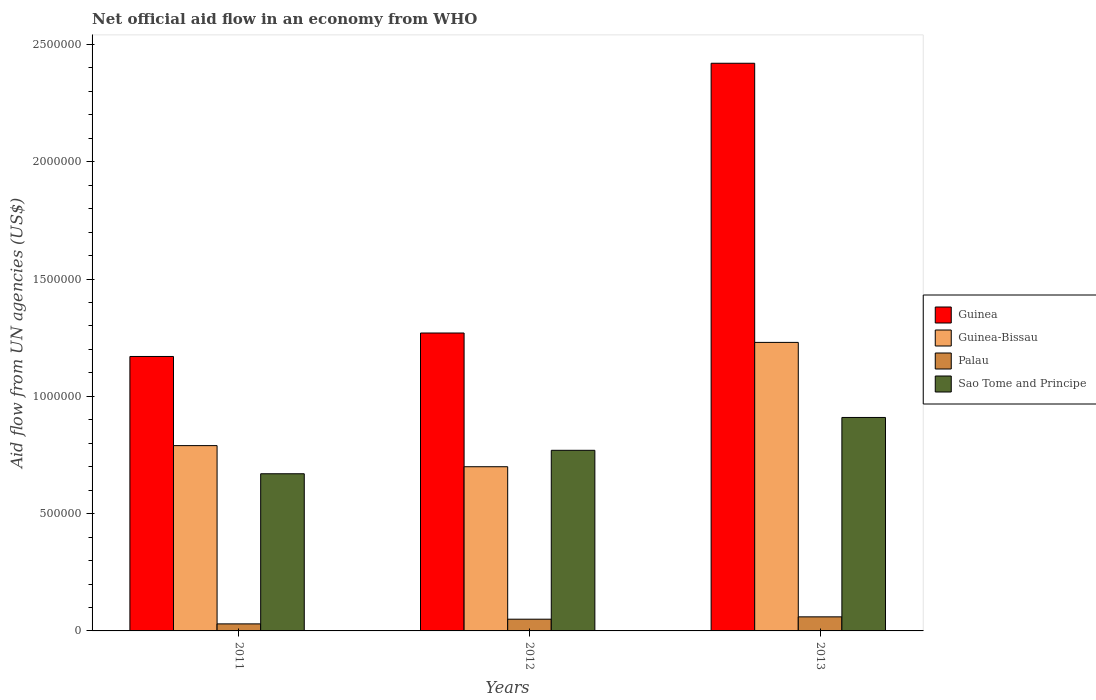How many bars are there on the 1st tick from the right?
Offer a terse response. 4. What is the net official aid flow in Guinea in 2012?
Your answer should be very brief. 1.27e+06. Across all years, what is the maximum net official aid flow in Sao Tome and Principe?
Offer a very short reply. 9.10e+05. Across all years, what is the minimum net official aid flow in Guinea?
Offer a terse response. 1.17e+06. In which year was the net official aid flow in Guinea maximum?
Your response must be concise. 2013. What is the total net official aid flow in Guinea in the graph?
Offer a very short reply. 4.86e+06. What is the difference between the net official aid flow in Guinea-Bissau in 2011 and that in 2013?
Make the answer very short. -4.40e+05. What is the difference between the net official aid flow in Guinea in 2011 and the net official aid flow in Palau in 2013?
Make the answer very short. 1.11e+06. What is the average net official aid flow in Guinea-Bissau per year?
Keep it short and to the point. 9.07e+05. In the year 2011, what is the difference between the net official aid flow in Guinea-Bissau and net official aid flow in Palau?
Offer a very short reply. 7.60e+05. What is the ratio of the net official aid flow in Palau in 2012 to that in 2013?
Offer a very short reply. 0.83. Is the difference between the net official aid flow in Guinea-Bissau in 2012 and 2013 greater than the difference between the net official aid flow in Palau in 2012 and 2013?
Provide a succinct answer. No. What is the difference between the highest and the second highest net official aid flow in Sao Tome and Principe?
Offer a terse response. 1.40e+05. What is the difference between the highest and the lowest net official aid flow in Guinea-Bissau?
Give a very brief answer. 5.30e+05. Is it the case that in every year, the sum of the net official aid flow in Guinea-Bissau and net official aid flow in Sao Tome and Principe is greater than the sum of net official aid flow in Palau and net official aid flow in Guinea?
Your response must be concise. Yes. What does the 3rd bar from the left in 2011 represents?
Keep it short and to the point. Palau. What does the 3rd bar from the right in 2013 represents?
Give a very brief answer. Guinea-Bissau. Is it the case that in every year, the sum of the net official aid flow in Guinea-Bissau and net official aid flow in Guinea is greater than the net official aid flow in Palau?
Make the answer very short. Yes. How many bars are there?
Your response must be concise. 12. What is the difference between two consecutive major ticks on the Y-axis?
Provide a succinct answer. 5.00e+05. Are the values on the major ticks of Y-axis written in scientific E-notation?
Offer a very short reply. No. Where does the legend appear in the graph?
Keep it short and to the point. Center right. How are the legend labels stacked?
Ensure brevity in your answer.  Vertical. What is the title of the graph?
Make the answer very short. Net official aid flow in an economy from WHO. Does "Philippines" appear as one of the legend labels in the graph?
Give a very brief answer. No. What is the label or title of the X-axis?
Your answer should be compact. Years. What is the label or title of the Y-axis?
Provide a short and direct response. Aid flow from UN agencies (US$). What is the Aid flow from UN agencies (US$) in Guinea in 2011?
Your answer should be very brief. 1.17e+06. What is the Aid flow from UN agencies (US$) in Guinea-Bissau in 2011?
Your answer should be compact. 7.90e+05. What is the Aid flow from UN agencies (US$) in Sao Tome and Principe in 2011?
Ensure brevity in your answer.  6.70e+05. What is the Aid flow from UN agencies (US$) of Guinea in 2012?
Your answer should be compact. 1.27e+06. What is the Aid flow from UN agencies (US$) in Guinea-Bissau in 2012?
Provide a succinct answer. 7.00e+05. What is the Aid flow from UN agencies (US$) of Sao Tome and Principe in 2012?
Provide a short and direct response. 7.70e+05. What is the Aid flow from UN agencies (US$) of Guinea in 2013?
Keep it short and to the point. 2.42e+06. What is the Aid flow from UN agencies (US$) of Guinea-Bissau in 2013?
Provide a succinct answer. 1.23e+06. What is the Aid flow from UN agencies (US$) in Palau in 2013?
Provide a short and direct response. 6.00e+04. What is the Aid flow from UN agencies (US$) in Sao Tome and Principe in 2013?
Give a very brief answer. 9.10e+05. Across all years, what is the maximum Aid flow from UN agencies (US$) of Guinea?
Provide a short and direct response. 2.42e+06. Across all years, what is the maximum Aid flow from UN agencies (US$) in Guinea-Bissau?
Your answer should be compact. 1.23e+06. Across all years, what is the maximum Aid flow from UN agencies (US$) of Sao Tome and Principe?
Your answer should be compact. 9.10e+05. Across all years, what is the minimum Aid flow from UN agencies (US$) of Guinea?
Your answer should be very brief. 1.17e+06. Across all years, what is the minimum Aid flow from UN agencies (US$) in Guinea-Bissau?
Give a very brief answer. 7.00e+05. Across all years, what is the minimum Aid flow from UN agencies (US$) of Palau?
Keep it short and to the point. 3.00e+04. Across all years, what is the minimum Aid flow from UN agencies (US$) in Sao Tome and Principe?
Keep it short and to the point. 6.70e+05. What is the total Aid flow from UN agencies (US$) in Guinea in the graph?
Provide a short and direct response. 4.86e+06. What is the total Aid flow from UN agencies (US$) in Guinea-Bissau in the graph?
Provide a short and direct response. 2.72e+06. What is the total Aid flow from UN agencies (US$) of Sao Tome and Principe in the graph?
Provide a short and direct response. 2.35e+06. What is the difference between the Aid flow from UN agencies (US$) in Guinea in 2011 and that in 2012?
Provide a succinct answer. -1.00e+05. What is the difference between the Aid flow from UN agencies (US$) in Palau in 2011 and that in 2012?
Provide a succinct answer. -2.00e+04. What is the difference between the Aid flow from UN agencies (US$) in Guinea in 2011 and that in 2013?
Your answer should be compact. -1.25e+06. What is the difference between the Aid flow from UN agencies (US$) of Guinea-Bissau in 2011 and that in 2013?
Give a very brief answer. -4.40e+05. What is the difference between the Aid flow from UN agencies (US$) of Palau in 2011 and that in 2013?
Offer a very short reply. -3.00e+04. What is the difference between the Aid flow from UN agencies (US$) in Guinea in 2012 and that in 2013?
Provide a short and direct response. -1.15e+06. What is the difference between the Aid flow from UN agencies (US$) of Guinea-Bissau in 2012 and that in 2013?
Make the answer very short. -5.30e+05. What is the difference between the Aid flow from UN agencies (US$) of Palau in 2012 and that in 2013?
Give a very brief answer. -10000. What is the difference between the Aid flow from UN agencies (US$) of Guinea in 2011 and the Aid flow from UN agencies (US$) of Guinea-Bissau in 2012?
Ensure brevity in your answer.  4.70e+05. What is the difference between the Aid flow from UN agencies (US$) of Guinea in 2011 and the Aid flow from UN agencies (US$) of Palau in 2012?
Your answer should be compact. 1.12e+06. What is the difference between the Aid flow from UN agencies (US$) of Guinea in 2011 and the Aid flow from UN agencies (US$) of Sao Tome and Principe in 2012?
Ensure brevity in your answer.  4.00e+05. What is the difference between the Aid flow from UN agencies (US$) of Guinea-Bissau in 2011 and the Aid flow from UN agencies (US$) of Palau in 2012?
Your answer should be very brief. 7.40e+05. What is the difference between the Aid flow from UN agencies (US$) of Palau in 2011 and the Aid flow from UN agencies (US$) of Sao Tome and Principe in 2012?
Ensure brevity in your answer.  -7.40e+05. What is the difference between the Aid flow from UN agencies (US$) of Guinea in 2011 and the Aid flow from UN agencies (US$) of Guinea-Bissau in 2013?
Your answer should be compact. -6.00e+04. What is the difference between the Aid flow from UN agencies (US$) of Guinea in 2011 and the Aid flow from UN agencies (US$) of Palau in 2013?
Keep it short and to the point. 1.11e+06. What is the difference between the Aid flow from UN agencies (US$) in Guinea in 2011 and the Aid flow from UN agencies (US$) in Sao Tome and Principe in 2013?
Your answer should be compact. 2.60e+05. What is the difference between the Aid flow from UN agencies (US$) of Guinea-Bissau in 2011 and the Aid flow from UN agencies (US$) of Palau in 2013?
Keep it short and to the point. 7.30e+05. What is the difference between the Aid flow from UN agencies (US$) in Palau in 2011 and the Aid flow from UN agencies (US$) in Sao Tome and Principe in 2013?
Your answer should be compact. -8.80e+05. What is the difference between the Aid flow from UN agencies (US$) in Guinea in 2012 and the Aid flow from UN agencies (US$) in Palau in 2013?
Offer a terse response. 1.21e+06. What is the difference between the Aid flow from UN agencies (US$) of Guinea in 2012 and the Aid flow from UN agencies (US$) of Sao Tome and Principe in 2013?
Your answer should be compact. 3.60e+05. What is the difference between the Aid flow from UN agencies (US$) of Guinea-Bissau in 2012 and the Aid flow from UN agencies (US$) of Palau in 2013?
Your answer should be compact. 6.40e+05. What is the difference between the Aid flow from UN agencies (US$) in Guinea-Bissau in 2012 and the Aid flow from UN agencies (US$) in Sao Tome and Principe in 2013?
Make the answer very short. -2.10e+05. What is the difference between the Aid flow from UN agencies (US$) in Palau in 2012 and the Aid flow from UN agencies (US$) in Sao Tome and Principe in 2013?
Provide a short and direct response. -8.60e+05. What is the average Aid flow from UN agencies (US$) of Guinea per year?
Offer a terse response. 1.62e+06. What is the average Aid flow from UN agencies (US$) of Guinea-Bissau per year?
Offer a terse response. 9.07e+05. What is the average Aid flow from UN agencies (US$) in Palau per year?
Your answer should be compact. 4.67e+04. What is the average Aid flow from UN agencies (US$) of Sao Tome and Principe per year?
Your answer should be compact. 7.83e+05. In the year 2011, what is the difference between the Aid flow from UN agencies (US$) in Guinea and Aid flow from UN agencies (US$) in Palau?
Your response must be concise. 1.14e+06. In the year 2011, what is the difference between the Aid flow from UN agencies (US$) in Guinea and Aid flow from UN agencies (US$) in Sao Tome and Principe?
Keep it short and to the point. 5.00e+05. In the year 2011, what is the difference between the Aid flow from UN agencies (US$) of Guinea-Bissau and Aid flow from UN agencies (US$) of Palau?
Your response must be concise. 7.60e+05. In the year 2011, what is the difference between the Aid flow from UN agencies (US$) of Palau and Aid flow from UN agencies (US$) of Sao Tome and Principe?
Provide a short and direct response. -6.40e+05. In the year 2012, what is the difference between the Aid flow from UN agencies (US$) of Guinea and Aid flow from UN agencies (US$) of Guinea-Bissau?
Your response must be concise. 5.70e+05. In the year 2012, what is the difference between the Aid flow from UN agencies (US$) of Guinea and Aid flow from UN agencies (US$) of Palau?
Offer a terse response. 1.22e+06. In the year 2012, what is the difference between the Aid flow from UN agencies (US$) in Guinea and Aid flow from UN agencies (US$) in Sao Tome and Principe?
Give a very brief answer. 5.00e+05. In the year 2012, what is the difference between the Aid flow from UN agencies (US$) of Guinea-Bissau and Aid flow from UN agencies (US$) of Palau?
Your answer should be compact. 6.50e+05. In the year 2012, what is the difference between the Aid flow from UN agencies (US$) of Palau and Aid flow from UN agencies (US$) of Sao Tome and Principe?
Offer a terse response. -7.20e+05. In the year 2013, what is the difference between the Aid flow from UN agencies (US$) of Guinea and Aid flow from UN agencies (US$) of Guinea-Bissau?
Keep it short and to the point. 1.19e+06. In the year 2013, what is the difference between the Aid flow from UN agencies (US$) of Guinea and Aid flow from UN agencies (US$) of Palau?
Keep it short and to the point. 2.36e+06. In the year 2013, what is the difference between the Aid flow from UN agencies (US$) in Guinea and Aid flow from UN agencies (US$) in Sao Tome and Principe?
Ensure brevity in your answer.  1.51e+06. In the year 2013, what is the difference between the Aid flow from UN agencies (US$) of Guinea-Bissau and Aid flow from UN agencies (US$) of Palau?
Give a very brief answer. 1.17e+06. In the year 2013, what is the difference between the Aid flow from UN agencies (US$) of Guinea-Bissau and Aid flow from UN agencies (US$) of Sao Tome and Principe?
Your answer should be compact. 3.20e+05. In the year 2013, what is the difference between the Aid flow from UN agencies (US$) in Palau and Aid flow from UN agencies (US$) in Sao Tome and Principe?
Provide a succinct answer. -8.50e+05. What is the ratio of the Aid flow from UN agencies (US$) of Guinea in 2011 to that in 2012?
Your answer should be compact. 0.92. What is the ratio of the Aid flow from UN agencies (US$) in Guinea-Bissau in 2011 to that in 2012?
Ensure brevity in your answer.  1.13. What is the ratio of the Aid flow from UN agencies (US$) in Palau in 2011 to that in 2012?
Keep it short and to the point. 0.6. What is the ratio of the Aid flow from UN agencies (US$) of Sao Tome and Principe in 2011 to that in 2012?
Provide a succinct answer. 0.87. What is the ratio of the Aid flow from UN agencies (US$) in Guinea in 2011 to that in 2013?
Keep it short and to the point. 0.48. What is the ratio of the Aid flow from UN agencies (US$) in Guinea-Bissau in 2011 to that in 2013?
Provide a succinct answer. 0.64. What is the ratio of the Aid flow from UN agencies (US$) in Palau in 2011 to that in 2013?
Your answer should be very brief. 0.5. What is the ratio of the Aid flow from UN agencies (US$) in Sao Tome and Principe in 2011 to that in 2013?
Provide a short and direct response. 0.74. What is the ratio of the Aid flow from UN agencies (US$) in Guinea in 2012 to that in 2013?
Your answer should be very brief. 0.52. What is the ratio of the Aid flow from UN agencies (US$) in Guinea-Bissau in 2012 to that in 2013?
Give a very brief answer. 0.57. What is the ratio of the Aid flow from UN agencies (US$) in Palau in 2012 to that in 2013?
Ensure brevity in your answer.  0.83. What is the ratio of the Aid flow from UN agencies (US$) of Sao Tome and Principe in 2012 to that in 2013?
Your answer should be very brief. 0.85. What is the difference between the highest and the second highest Aid flow from UN agencies (US$) in Guinea?
Ensure brevity in your answer.  1.15e+06. What is the difference between the highest and the second highest Aid flow from UN agencies (US$) of Guinea-Bissau?
Keep it short and to the point. 4.40e+05. What is the difference between the highest and the lowest Aid flow from UN agencies (US$) of Guinea?
Give a very brief answer. 1.25e+06. What is the difference between the highest and the lowest Aid flow from UN agencies (US$) in Guinea-Bissau?
Give a very brief answer. 5.30e+05. What is the difference between the highest and the lowest Aid flow from UN agencies (US$) of Sao Tome and Principe?
Your response must be concise. 2.40e+05. 